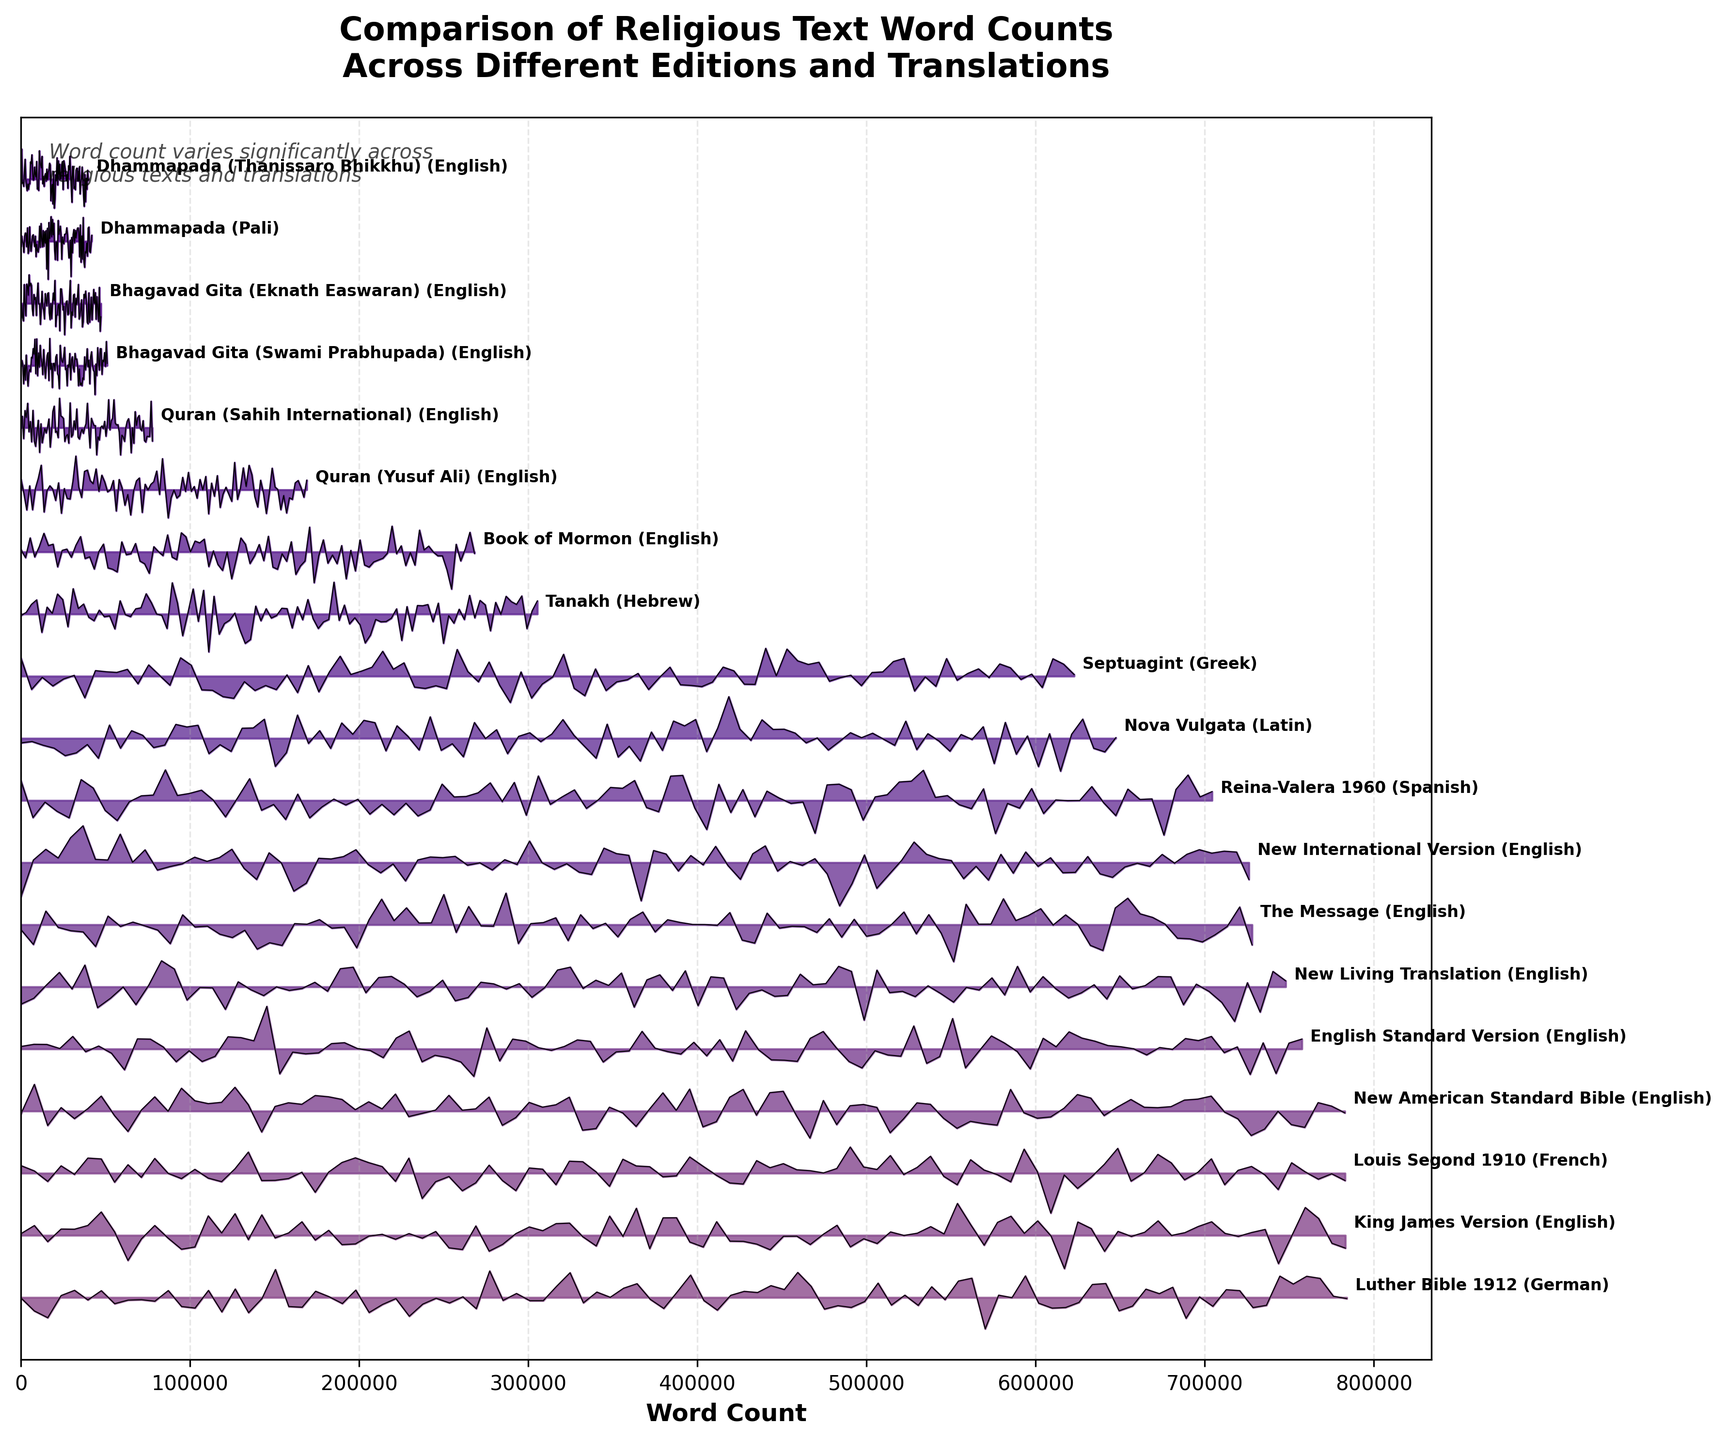What is the highest word count for any religious text displayed in the plot? The figure's ridgeline plot shows different texts sorted by word count in descending order. The topmost ridge represents the text with the highest word count. According to the data, the "Luther Bible 1912" in German has the highest word count.
Answer: 783981 What is the total word count of the three editions with the lowest word counts? Sum the word counts of the three texts with the lowest values in the plot: "Dhammapada (Thanissaro Bhikkhu)" (39759), "Dhammapada" (41836), and "Bhagavad Gita (Eknath Easwaran)" (47275). Total = 39759 + 41836 + 47275 = 128870.
Answer: 128870 How does the word count of the Tanakh compare to the Nova Vulgata? Observe the positions of the Tanakh and Nova Vulgata in the ridgeline plot and note their word counts: Tanakh (305358) and Nova Vulgata (647422). The Tanakh has a lower word count than Nova Vulgata.
Answer: The Tanakh has a lower word count Which English translation of the Quran has more words: Sahih International or Yusuf Ali? The figure shows two English translations of the Quran. The ridgeline plot displays "Quran (Sahih International)" and "Quran (Yusuf Ali)". By comparing their lengths on the x-axis, the Yusuf Ali version has a higher word count (168993 vs 77701).
Answer: Yusuf Ali What is the difference in word count between the King James Version and The Message versions of the Bible? Identify the King James Version (783137) and The Message (727969) on the plot. Subtract the word count of The Message from the King James Version. Difference = 783137 - 727969 = 55168.
Answer: 55168 How many editions have a word count greater than 750000? Count the ridges in the plot with word counts exceeding 750000: "Luther Bible 1912," "King James Version," "New American Standard Bible," "Louis Segond 1910," "English Standard Version." There are five such texts.
Answer: 5 Which edition of the Bhagavad Gita has a higher word count: Eknath Easwaran or Swami Prabhupada? Compare the heights of the ridges for "Bhagavad Gita (Eknath Easwaran)" and "Bhagavad Gita (Swami Prabhupada)." The Swami Prabhupada translation has 50976 words, which is more than the 47275 words in the Eknath Easwaran edition.
Answer: Swami Prabhupada What is the range of word counts for the editions shown in the plot? The range is calculated as the difference between the maximum and minimum word counts in the plot. Max (Luther Bible 1912 - 783981) and Min (Dhammapada (Thanissaro Bhikkhu) - 39759), so Range = 783981 - 39759 = 744222.
Answer: 744222 What is the average word count of the listed English translations of the Bible? English Bible translations listed: King James Version (783137), New International Version (726109), English Standard Version (757439), New American Standard Bible (782815), New Living Translation (747851), The Message (727969). Calculate the mean: (783137 + 726109 + 757439 + 782815 + 747851 + 727969) / 6 = 753886.667.
Answer: 753887 